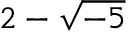Convert formula to latex. <formula><loc_0><loc_0><loc_500><loc_500>2 - { \sqrt { - 5 } }</formula> 